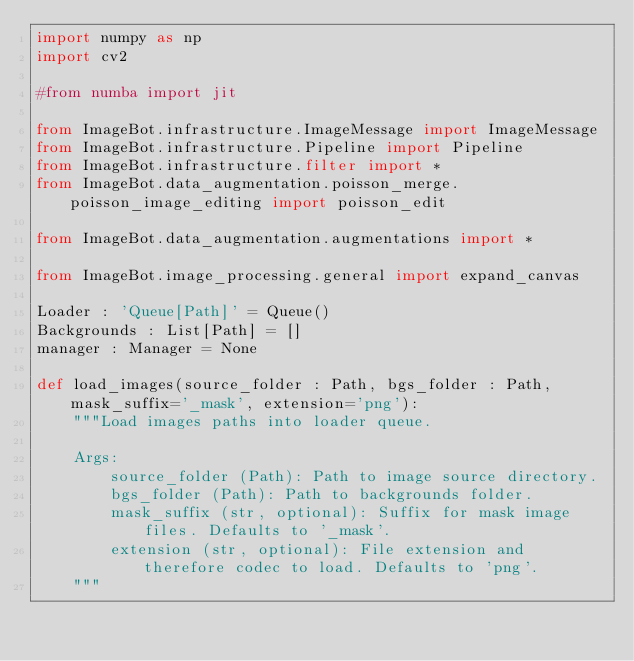Convert code to text. <code><loc_0><loc_0><loc_500><loc_500><_Python_>import numpy as np
import cv2

#from numba import jit

from ImageBot.infrastructure.ImageMessage import ImageMessage
from ImageBot.infrastructure.Pipeline import Pipeline
from ImageBot.infrastructure.filter import *
from ImageBot.data_augmentation.poisson_merge.poisson_image_editing import poisson_edit

from ImageBot.data_augmentation.augmentations import *

from ImageBot.image_processing.general import expand_canvas

Loader : 'Queue[Path]' = Queue()
Backgrounds : List[Path] = []
manager : Manager = None

def load_images(source_folder : Path, bgs_folder : Path, mask_suffix='_mask', extension='png'):
    """Load images paths into loader queue.

    Args:
        source_folder (Path): Path to image source directory.
        bgs_folder (Path): Path to backgrounds folder.
        mask_suffix (str, optional): Suffix for mask image files. Defaults to '_mask'.
        extension (str, optional): File extension and therefore codec to load. Defaults to 'png'.
    """</code> 